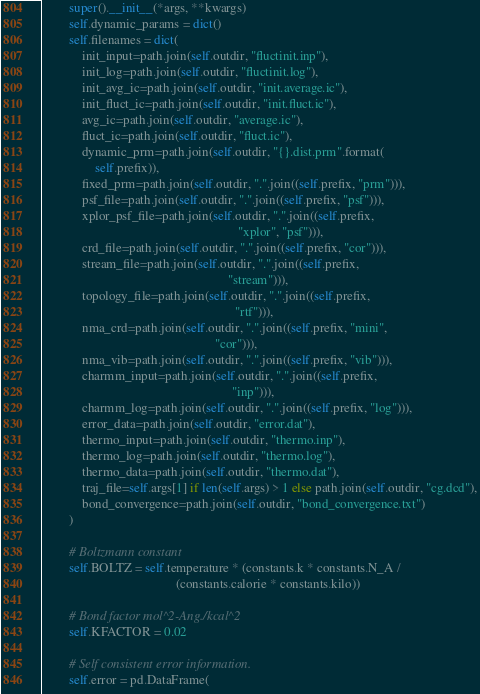Convert code to text. <code><loc_0><loc_0><loc_500><loc_500><_Python_>        super().__init__(*args, **kwargs)
        self.dynamic_params = dict()
        self.filenames = dict(
            init_input=path.join(self.outdir, "fluctinit.inp"),
            init_log=path.join(self.outdir, "fluctinit.log"),
            init_avg_ic=path.join(self.outdir, "init.average.ic"),
            init_fluct_ic=path.join(self.outdir, "init.fluct.ic"),
            avg_ic=path.join(self.outdir, "average.ic"),
            fluct_ic=path.join(self.outdir, "fluct.ic"),
            dynamic_prm=path.join(self.outdir, "{}.dist.prm".format(
                self.prefix)),
            fixed_prm=path.join(self.outdir, ".".join((self.prefix, "prm"))),
            psf_file=path.join(self.outdir, ".".join((self.prefix, "psf"))),
            xplor_psf_file=path.join(self.outdir, ".".join((self.prefix,
                                                            "xplor", "psf"))),
            crd_file=path.join(self.outdir, ".".join((self.prefix, "cor"))),
            stream_file=path.join(self.outdir, ".".join((self.prefix,
                                                         "stream"))),
            topology_file=path.join(self.outdir, ".".join((self.prefix,
                                                           "rtf"))),
            nma_crd=path.join(self.outdir, ".".join((self.prefix, "mini",
                                                     "cor"))),
            nma_vib=path.join(self.outdir, ".".join((self.prefix, "vib"))),
            charmm_input=path.join(self.outdir, ".".join((self.prefix,
                                                          "inp"))),
            charmm_log=path.join(self.outdir, ".".join((self.prefix, "log"))),
            error_data=path.join(self.outdir, "error.dat"),
            thermo_input=path.join(self.outdir, "thermo.inp"),
            thermo_log=path.join(self.outdir, "thermo.log"),
            thermo_data=path.join(self.outdir, "thermo.dat"),
            traj_file=self.args[1] if len(self.args) > 1 else path.join(self.outdir, "cg.dcd"),
            bond_convergence=path.join(self.outdir, "bond_convergence.txt")
        )

        # Boltzmann constant
        self.BOLTZ = self.temperature * (constants.k * constants.N_A /
                                         (constants.calorie * constants.kilo))

        # Bond factor mol^2-Ang./kcal^2
        self.KFACTOR = 0.02

        # Self consistent error information.
        self.error = pd.DataFrame(</code> 